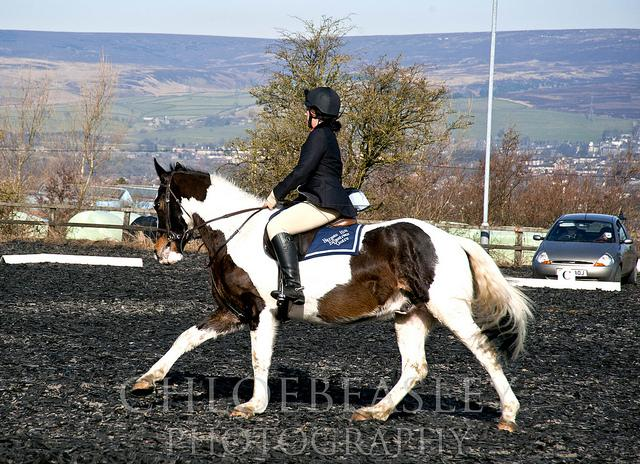What is on top of the horse? rider 